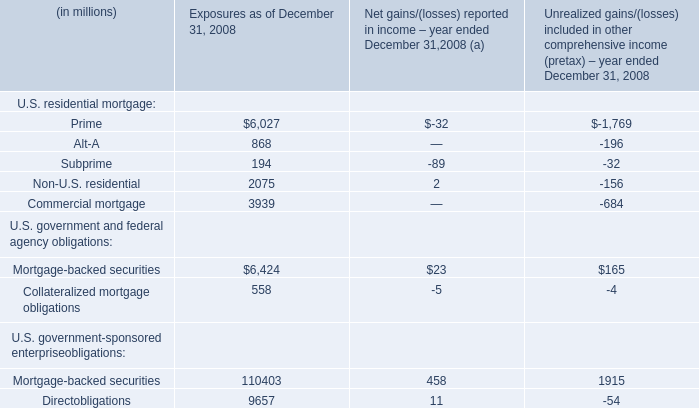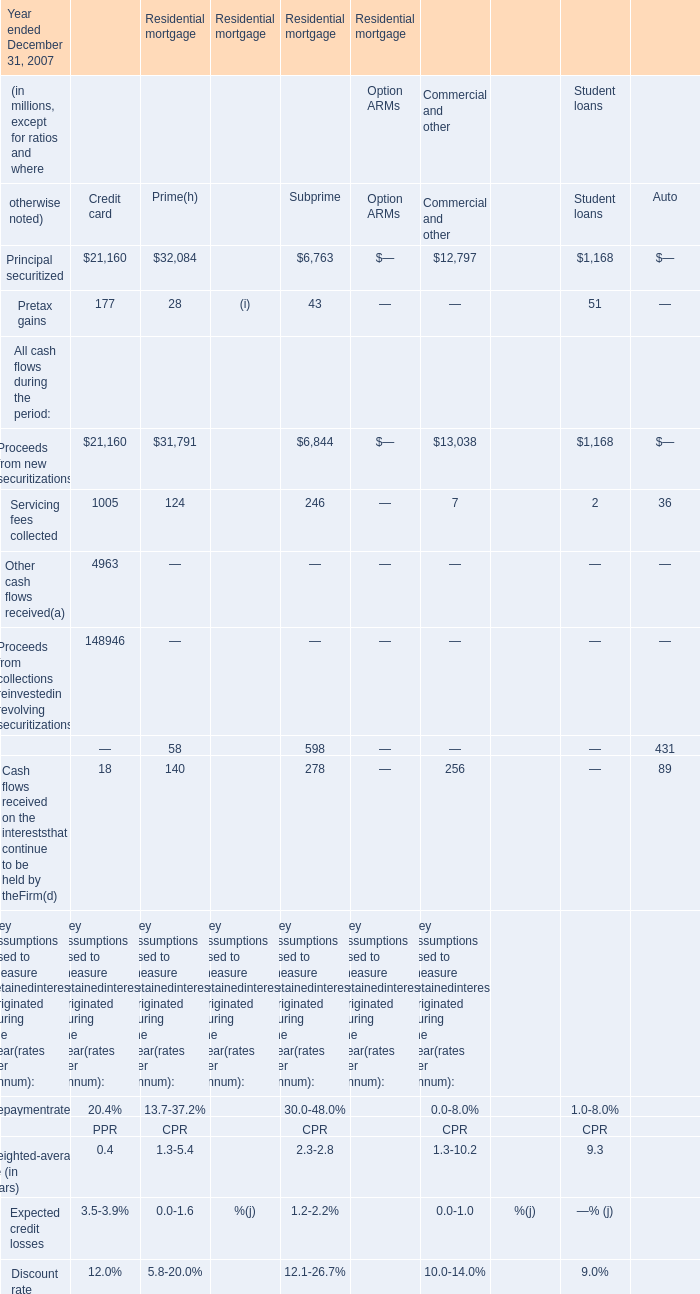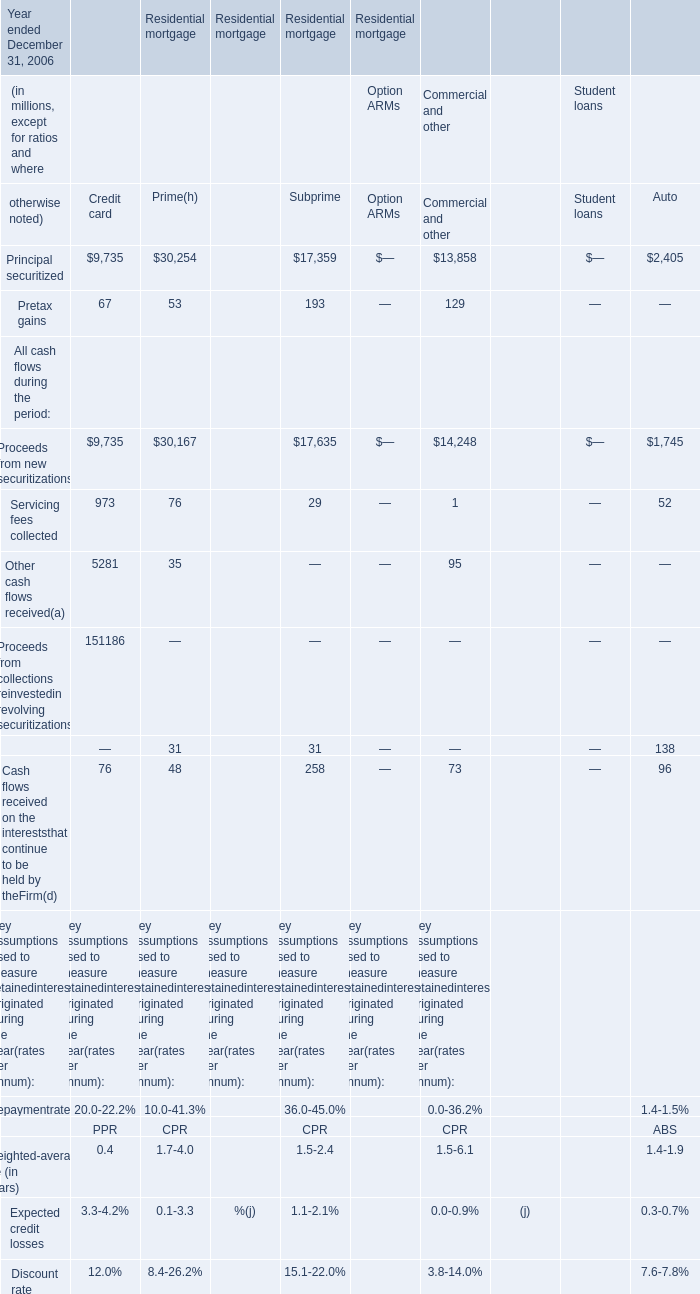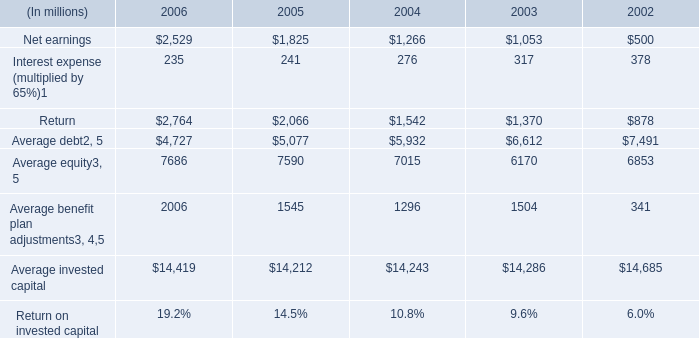What's the sum of Principal securitized of Residential mortgage Prime, and Average benefit plan adjustments of 2003 ? 
Computations: (32084.0 + 1504.0)
Answer: 33588.0. 